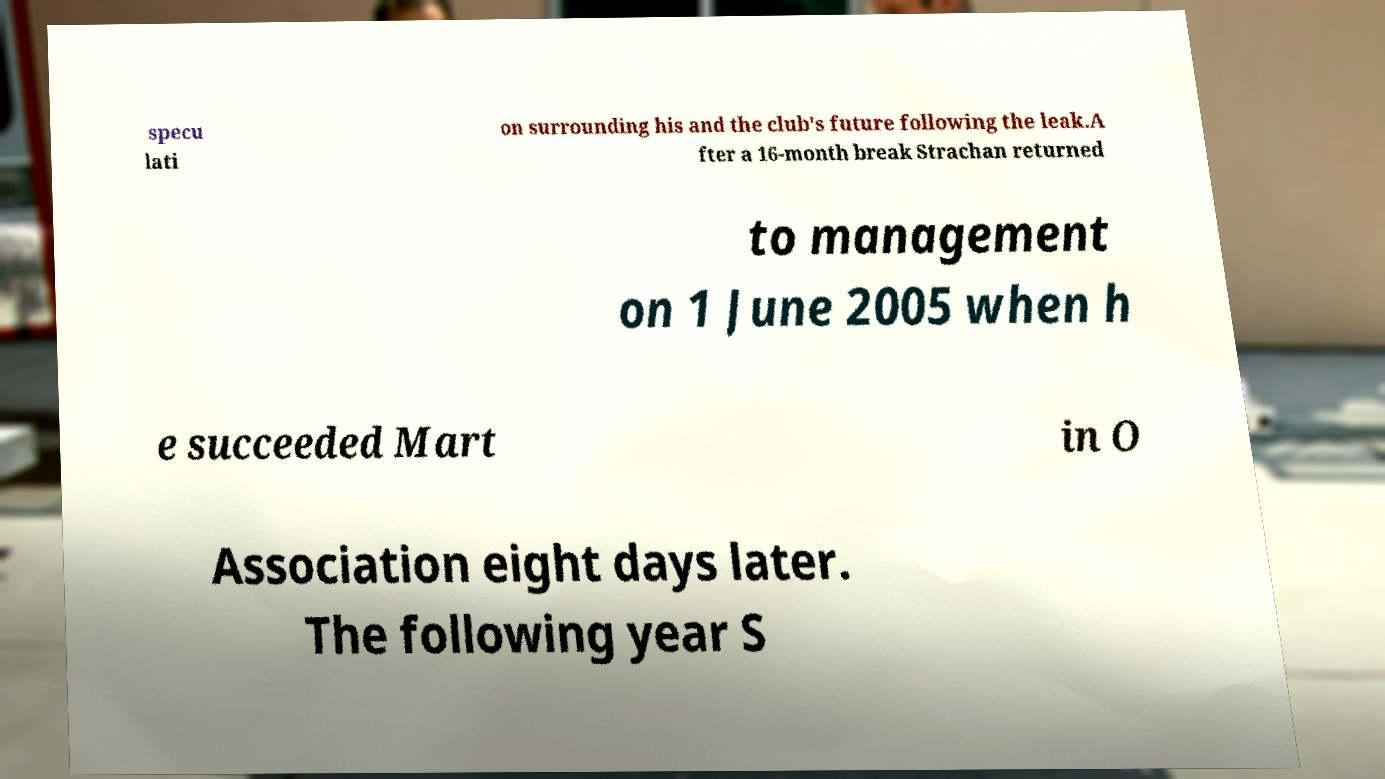Could you extract and type out the text from this image? specu lati on surrounding his and the club's future following the leak.A fter a 16-month break Strachan returned to management on 1 June 2005 when h e succeeded Mart in O Association eight days later. The following year S 